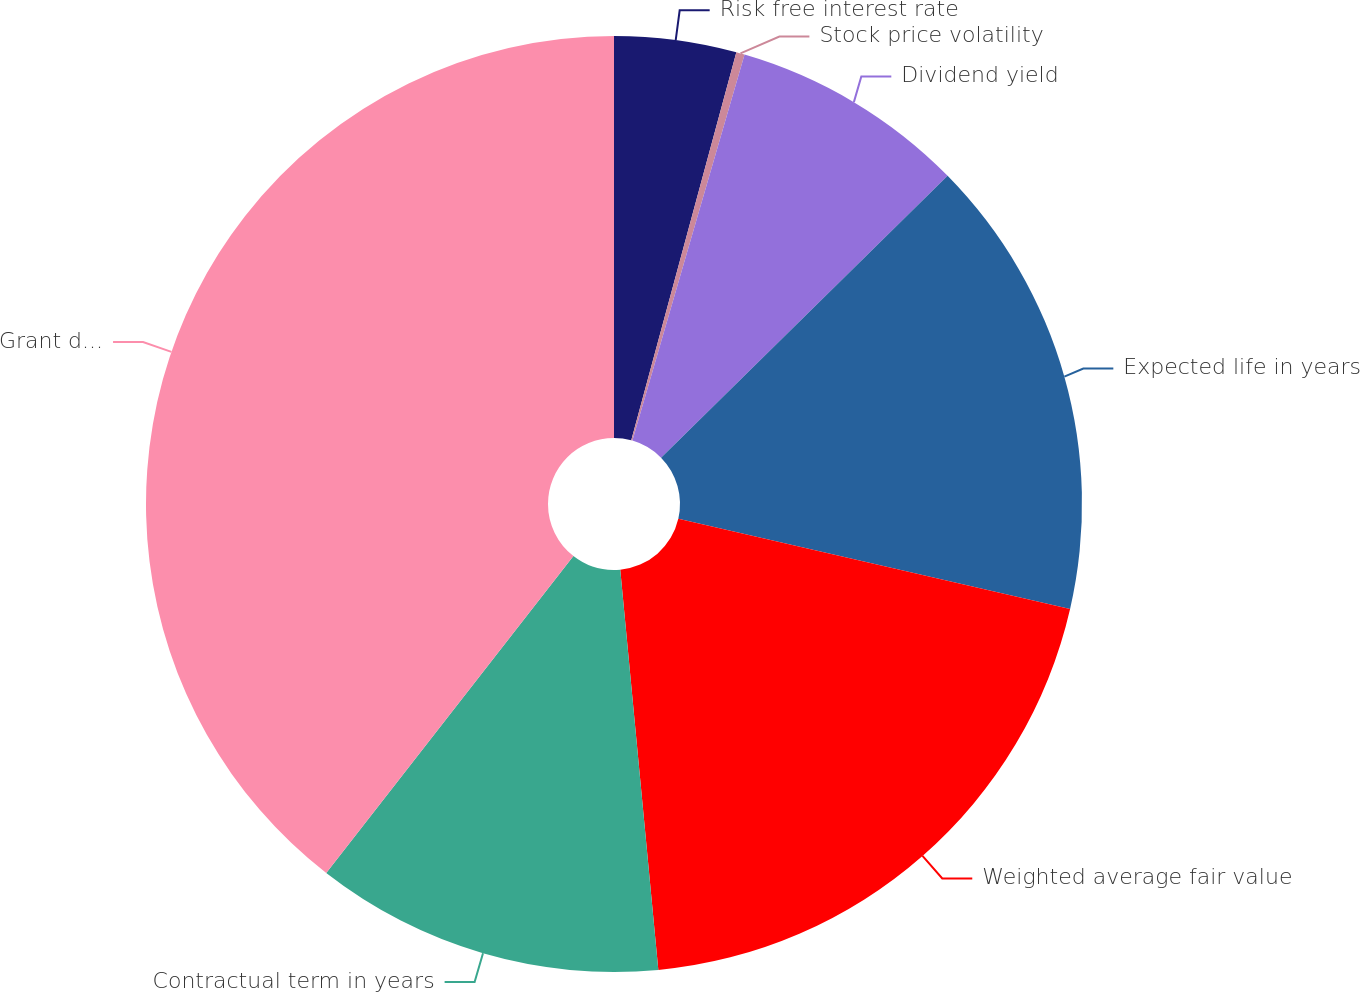<chart> <loc_0><loc_0><loc_500><loc_500><pie_chart><fcel>Risk free interest rate<fcel>Stock price volatility<fcel>Dividend yield<fcel>Expected life in years<fcel>Weighted average fair value<fcel>Contractual term in years<fcel>Grant date price of Hess<nl><fcel>4.21%<fcel>0.29%<fcel>8.13%<fcel>15.97%<fcel>19.89%<fcel>12.05%<fcel>39.46%<nl></chart> 